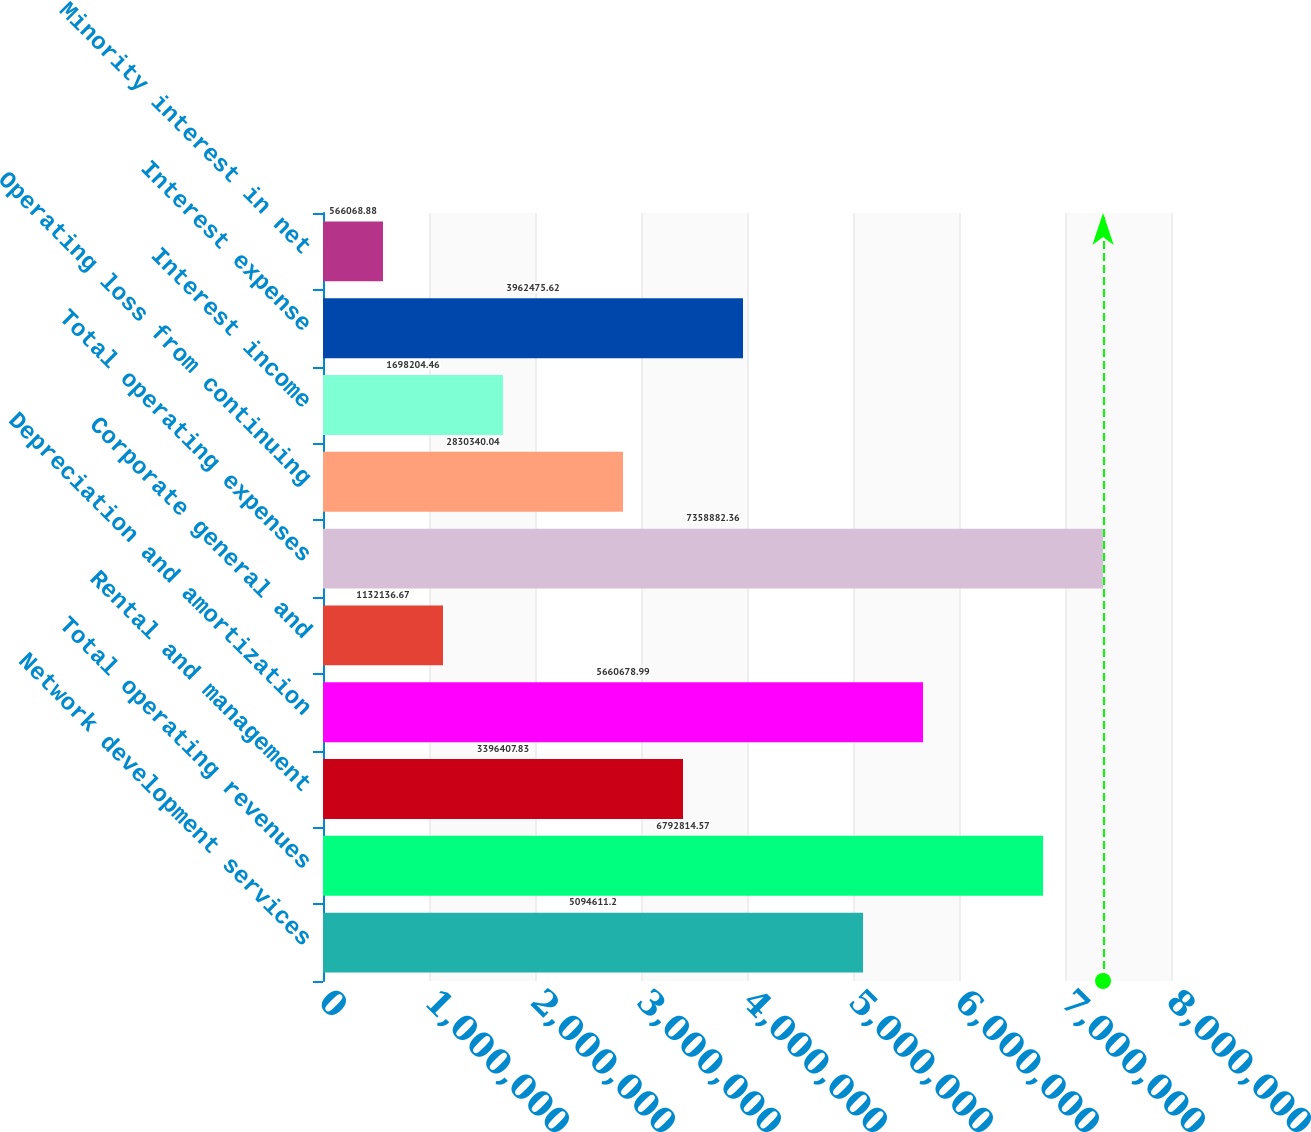<chart> <loc_0><loc_0><loc_500><loc_500><bar_chart><fcel>Network development services<fcel>Total operating revenues<fcel>Rental and management<fcel>Depreciation and amortization<fcel>Corporate general and<fcel>Total operating expenses<fcel>Operating loss from continuing<fcel>Interest income<fcel>Interest expense<fcel>Minority interest in net<nl><fcel>5.09461e+06<fcel>6.79281e+06<fcel>3.39641e+06<fcel>5.66068e+06<fcel>1.13214e+06<fcel>7.35888e+06<fcel>2.83034e+06<fcel>1.6982e+06<fcel>3.96248e+06<fcel>566069<nl></chart> 